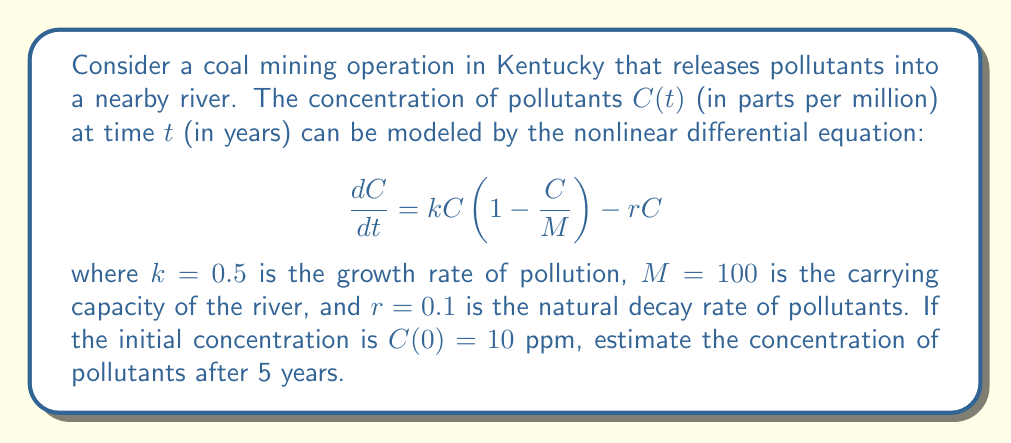Can you solve this math problem? To solve this problem, we'll use the following steps:

1) First, we need to identify the type of equation. This is a logistic growth model with an additional decay term.

2) The equation cannot be solved analytically, so we'll use a numerical method. Let's use Euler's method with a step size of $h=1$ year.

3) Euler's method is given by: $C_{n+1} = C_n + h \cdot f(C_n)$, where $f(C) = kC(1-\frac{C}{M}) - rC$

4) Let's calculate the values for each year:

   For $t=0$: $C_0 = 10$
   
   For $t=1$: 
   $$C_1 = C_0 + h \cdot [kC_0(1-\frac{C_0}{M}) - rC_0]$$
   $$= 10 + 1 \cdot [0.5 \cdot 10(1-\frac{10}{100}) - 0.1 \cdot 10] = 13.5$$

   For $t=2$: 
   $$C_2 = 13.5 + 1 \cdot [0.5 \cdot 13.5(1-\frac{13.5}{100}) - 0.1 \cdot 13.5] = 17.22$$

   For $t=3$: 
   $$C_3 = 17.22 + 1 \cdot [0.5 \cdot 17.22(1-\frac{17.22}{100}) - 0.1 \cdot 17.22] = 20.82$$

   For $t=4$: 
   $$C_4 = 20.82 + 1 \cdot [0.5 \cdot 20.82(1-\frac{20.82}{100}) - 0.1 \cdot 20.82] = 24.13$$

   For $t=5$: 
   $$C_5 = 24.13 + 1 \cdot [0.5 \cdot 24.13(1-\frac{24.13}{100}) - 0.1 \cdot 24.13] = 27.07$$

5) Therefore, after 5 years, the estimated concentration of pollutants is approximately 27.07 ppm.
Answer: 27.07 ppm 